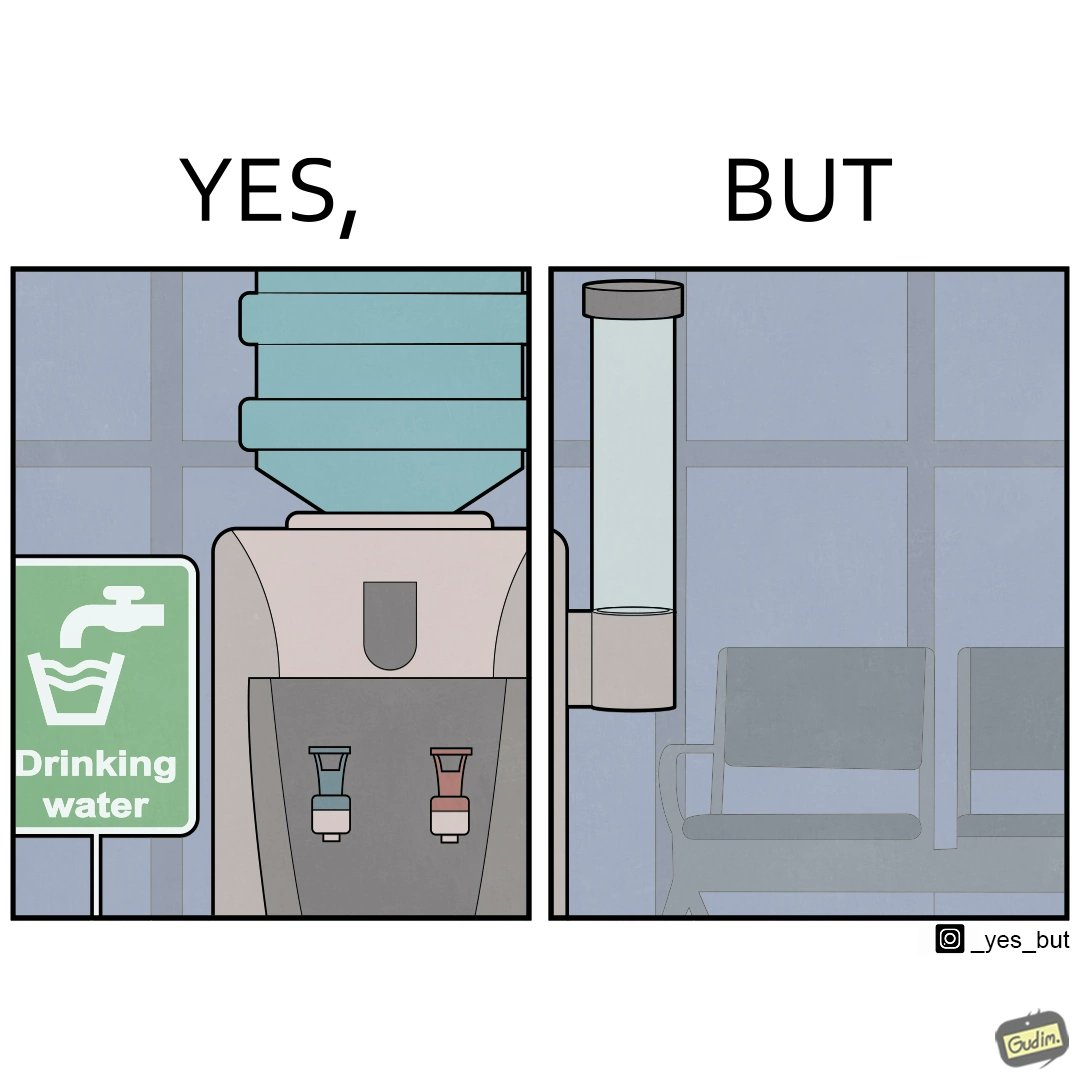What is shown in the left half versus the right half of this image? In the left part of the image: It is a drinking water dispenser In the right part of the image: It is an empty cup dispenser 